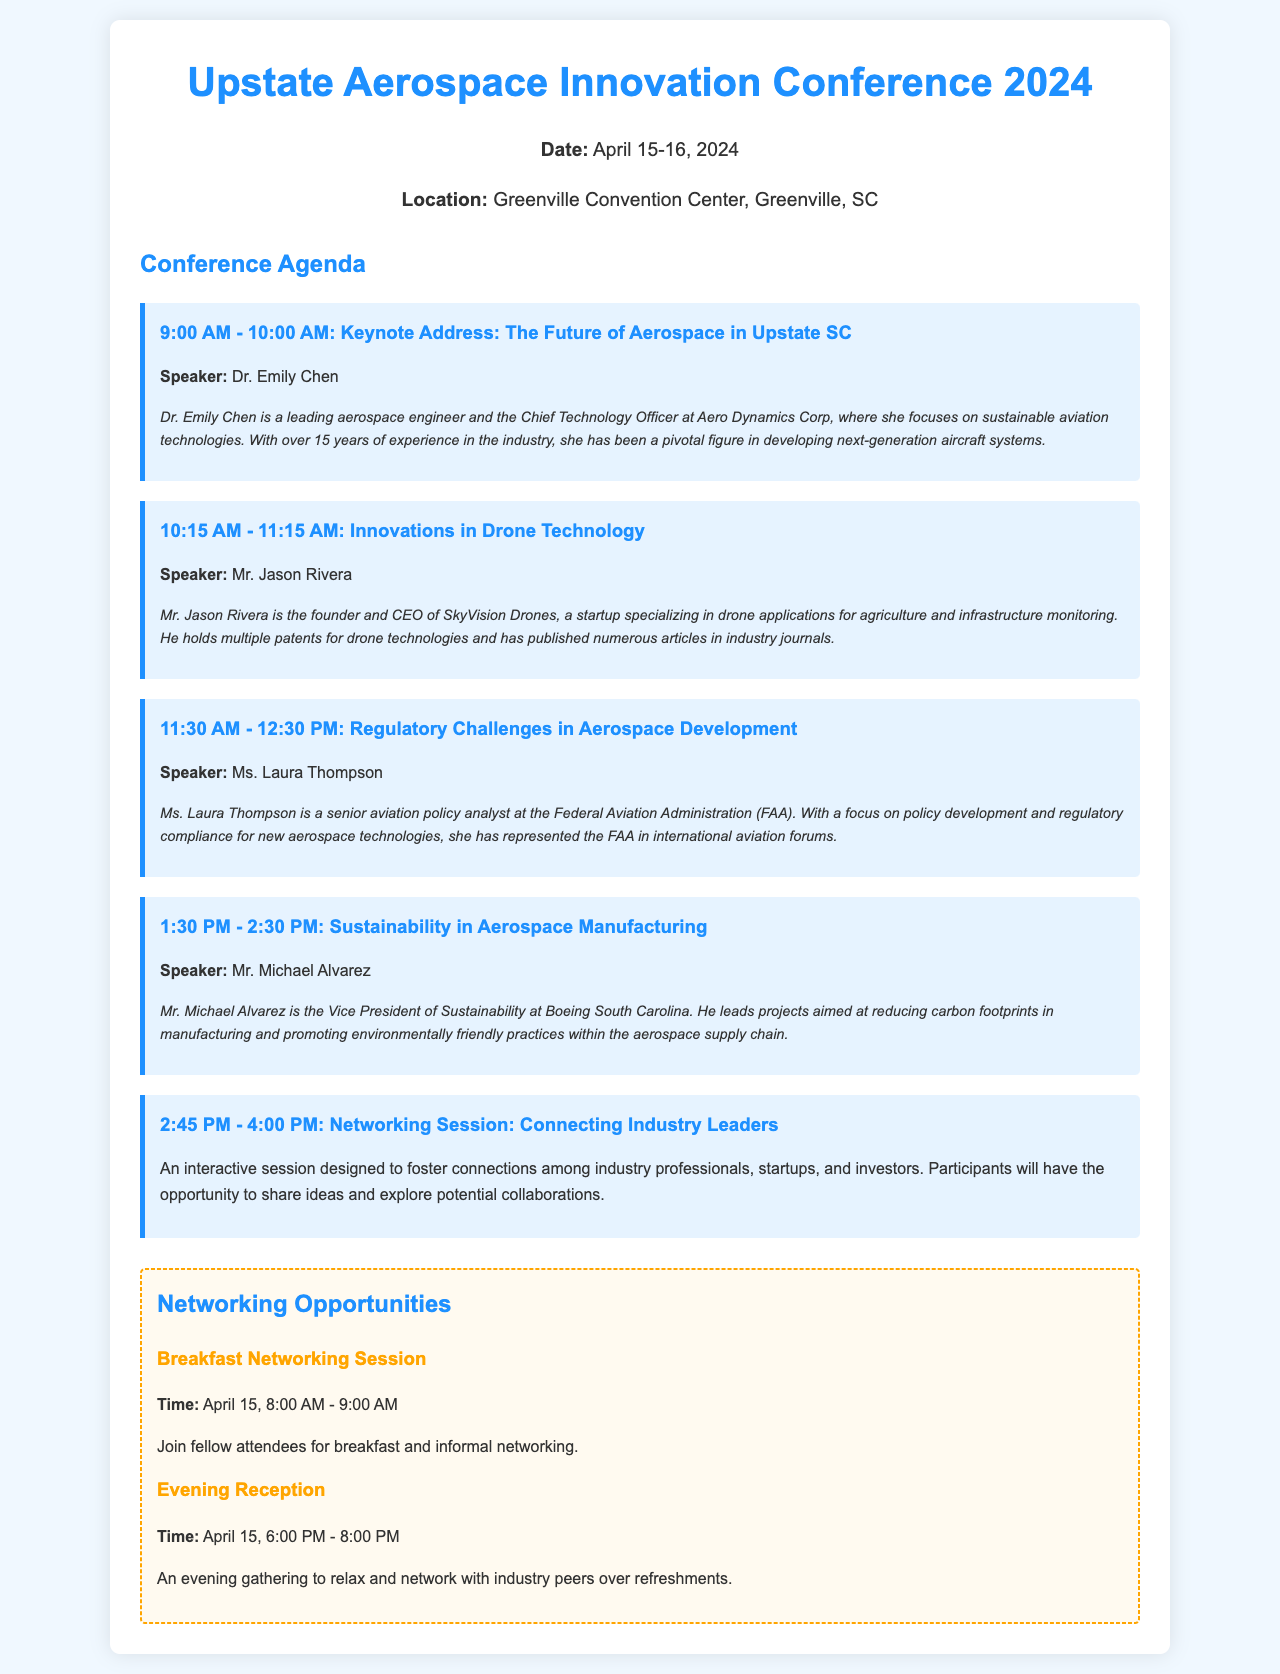What is the date of the conference? The date is mentioned at the beginning of the agenda and is April 15-16, 2024.
Answer: April 15-16, 2024 Who is the keynote speaker? The keynote address lists Dr. Emily Chen as the speaker.
Answer: Dr. Emily Chen What topic does Michael Alvarez speak about? The agenda item for Michael Alvarez specifies his session on Sustainability in Aerospace Manufacturing.
Answer: Sustainability in Aerospace Manufacturing What time is the breakfast networking session? The networking section lists the time for the breakfast session as April 15, 8:00 AM - 9:00 AM.
Answer: April 15, 8:00 AM - 9:00 AM How many sessions are scheduled before the networking session? By reviewing the agenda items listed, there are four sessions scheduled before the networking session.
Answer: Four Who represents the FAA at the conference? The session on Regulatory Challenges lists Ms. Laura Thompson as the FAA representative.
Answer: Ms. Laura Thompson What is the purpose of the 2:45 PM - 4:00 PM session? The networking session description indicates it aims to foster connections among industry professionals and explore collaborations.
Answer: Foster connections What is the location of the conference? The event information specifies that the location is the Greenville Convention Center, Greenville, SC.
Answer: Greenville Convention Center, Greenville, SC When does the evening reception take place? The networking section clearly states that the evening reception is scheduled for April 15, 6:00 PM - 8:00 PM.
Answer: April 15, 6:00 PM - 8:00 PM 